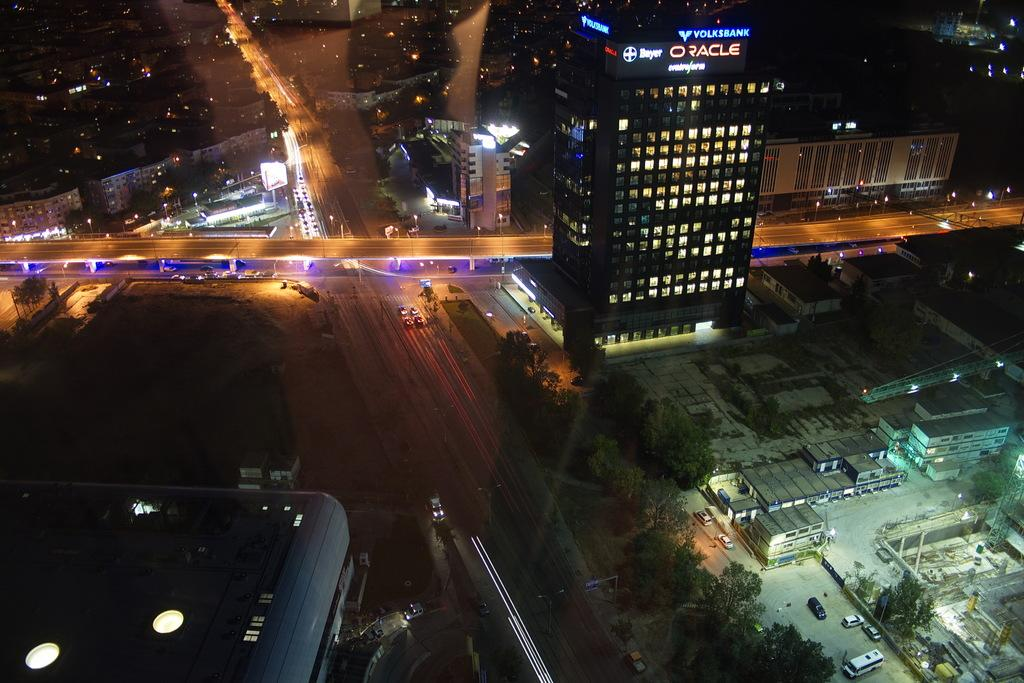What type of meeting is taking place in the image? There is no meeting present in the image; it features buildings, lights, trees, and vehicles on roads. What type of division can be seen in the image? There is no division present in the image; it shows a scene with buildings, lights, trees, and vehicles on roads. What thought is being expressed by the trees in the image? Trees do not have the ability to express thoughts, and there is no indication of any thought being expressed in the image. What type of division can be seen in the image? There is no division present in the image; it shows a scene with buildings, lights, trees, and vehicles on roads. 